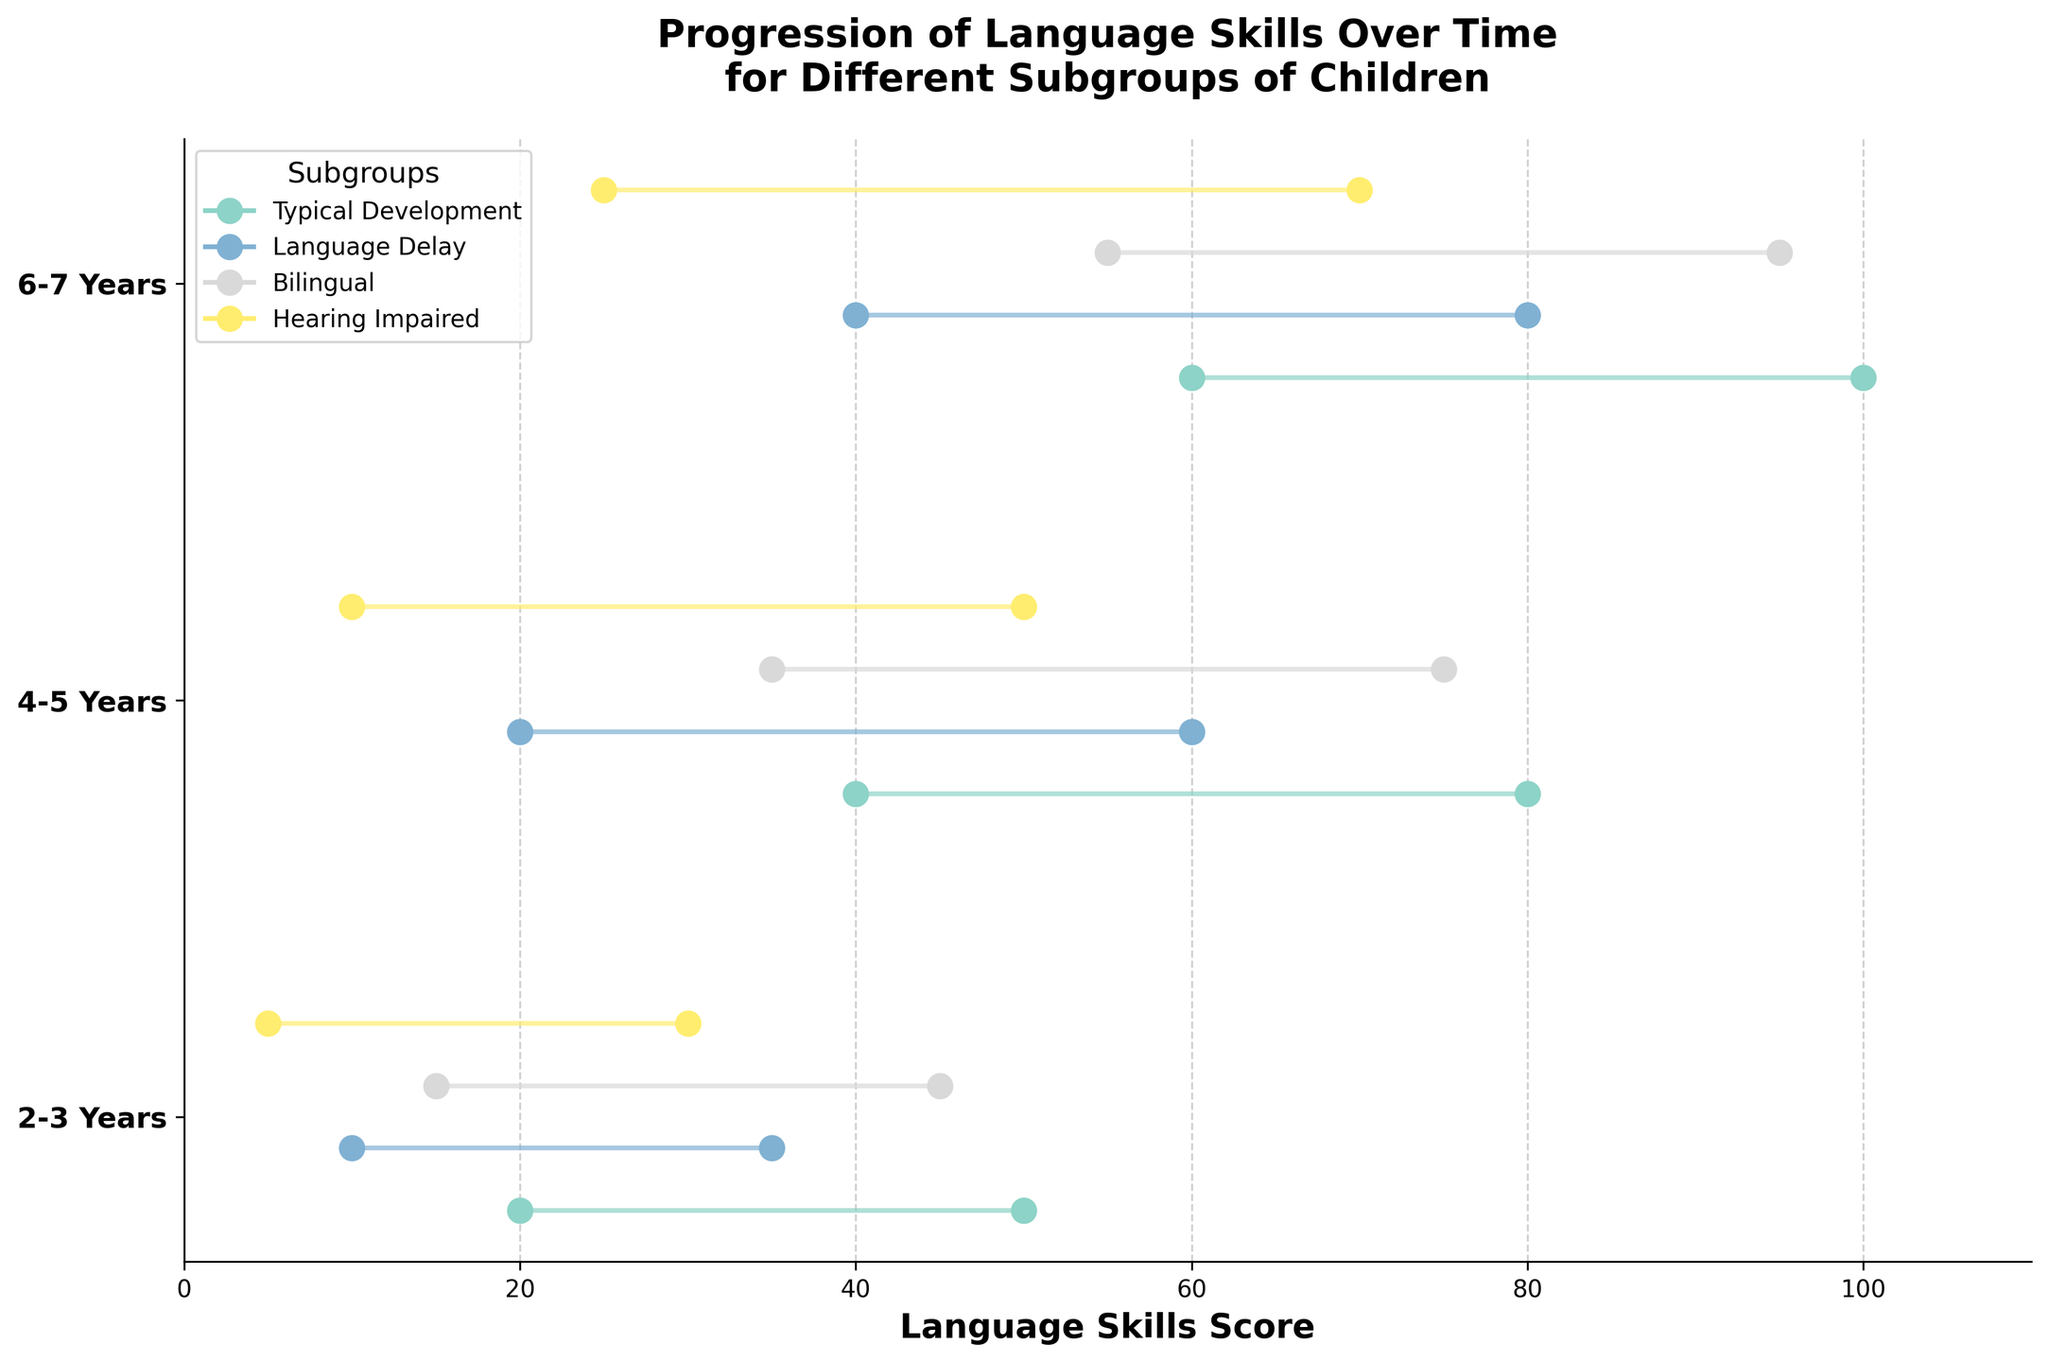Which subgroup of children aged 2-3 years has the highest maximum language skills score? Looking at the range for the "2-3 Years" age group, the subgroup "Typical Development" has the highest maximum language skills score, which is 50.
Answer: Typical Development What is the range of language skills score for the Hearing Impaired subgroup in the 4-5 years age group? The range of language skills scores is calculated by subtracting the minimum score from the maximum score. For the "Hearing Impaired" subgroup in the "4-5 Years" age group, the range is 50 - 10 = 40.
Answer: 40 Which age group has the widest range of language skills scores for the Bilingual subgroup? To find the widest range, compare the differences between the maximum and minimum language skills scores for the Bilingual subgroup across all age groups: 
2-3 Years: (45-15) = 30 
4-5 Years: (75-35) = 40 
6-7 Years: (95-55) = 40 
Both "4-5 Years" and "6-7 Years" have the widest range of 40.
Answer: 4-5 Years and 6-7 Years For children with a language delay, which age group shows the greatest improvement in their language skills score? Improvement can be measured by the increase in the maximum language skills score. Comparing the maximum scores for children with language delay across age groups: 
2-3 Years: 35 
4-5 Years: 60 
6-7 Years: 80 
The greatest improvement occurs going from "2-3 Years" to "4-5 Years" (60-35 = 25).
Answer: 4-5 Years Which subgroup has the lowest minimum language skills in the 6-7 years age group? Looking at the minimum language scores for the "6-7 Years" age group, the "Hearing Impaired" subgroup has the lowest minimum language skills score, which is 25.
Answer: Hearing Impaired What is the average maximum language skills score for the Typical Development subgroup across all age groups? To find the average, sum the maximum scores for the "Typical Development" subgroup and divide by the number of age groups:
2-3 Years: 50 
4-5 Years: 80 
6-7 Years: 100 
Sum = 50 + 80 + 100 = 230 
Number of age groups = 3 
Average = 230 / 3 ≈ 76.67
Answer: 76.67 How does the range of language skills for 2-3 year olds with typical development compare to those with a language delay? Calculate the range for each:
Typical Development: 50 - 20 = 30 
Language Delay: 35 - 10 = 25 
The range for typical development is 5 points wider than for those with a language delay.
Answer: 5 points wider Which age group shows the least variability in language skills scores across all subgroups? Calculate the range for each age group by finding the difference between the highest and lowest maximum scores:
2-3 Years: 50 (Typical Development) - 30 (Hearing Impaired) = 20 
4-5 Years: 80 (Typical Development) - 60 (Language Delay) = 20 
6-7 Years: 100 (Typical Development) - 70 (Hearing Impaired) = 30 
The "2-3 Years" and "4-5 Years" age groups show the least variability, both with a range of 20.
Answer: 2-3 Years and 4-5 Years 